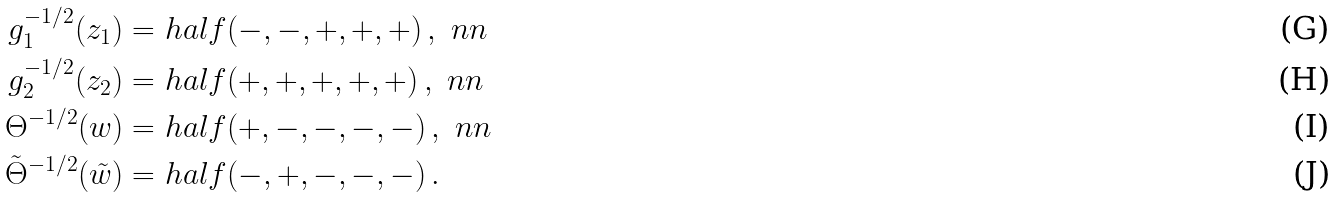Convert formula to latex. <formula><loc_0><loc_0><loc_500><loc_500>g _ { 1 } ^ { - 1 / 2 } ( z _ { 1 } ) = & \ h a l f ( - , - , + , + , + ) \, , \ n n \\ g _ { 2 } ^ { - 1 / 2 } ( z _ { 2 } ) = & \ h a l f ( + , + , + , + , + ) \, , \ n n \\ \Theta ^ { - 1 / 2 } ( w ) = & \ h a l f ( + , - , - , - , - ) \, , \ n n \\ \tilde { \Theta } ^ { - 1 / 2 } ( \tilde { w } ) = & \ h a l f ( - , + , - , - , - ) \, .</formula> 